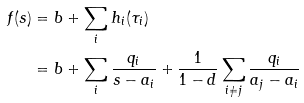<formula> <loc_0><loc_0><loc_500><loc_500>f ( s ) & = b + \sum _ { i } h _ { i } ( \tau _ { i } ) \\ & = b + \sum _ { i } \frac { q _ { i } } { s - a _ { i } } + \frac { 1 } { 1 - d } \sum _ { i \not = j } \frac { q _ { i } } { a _ { j } - a _ { i } }</formula> 